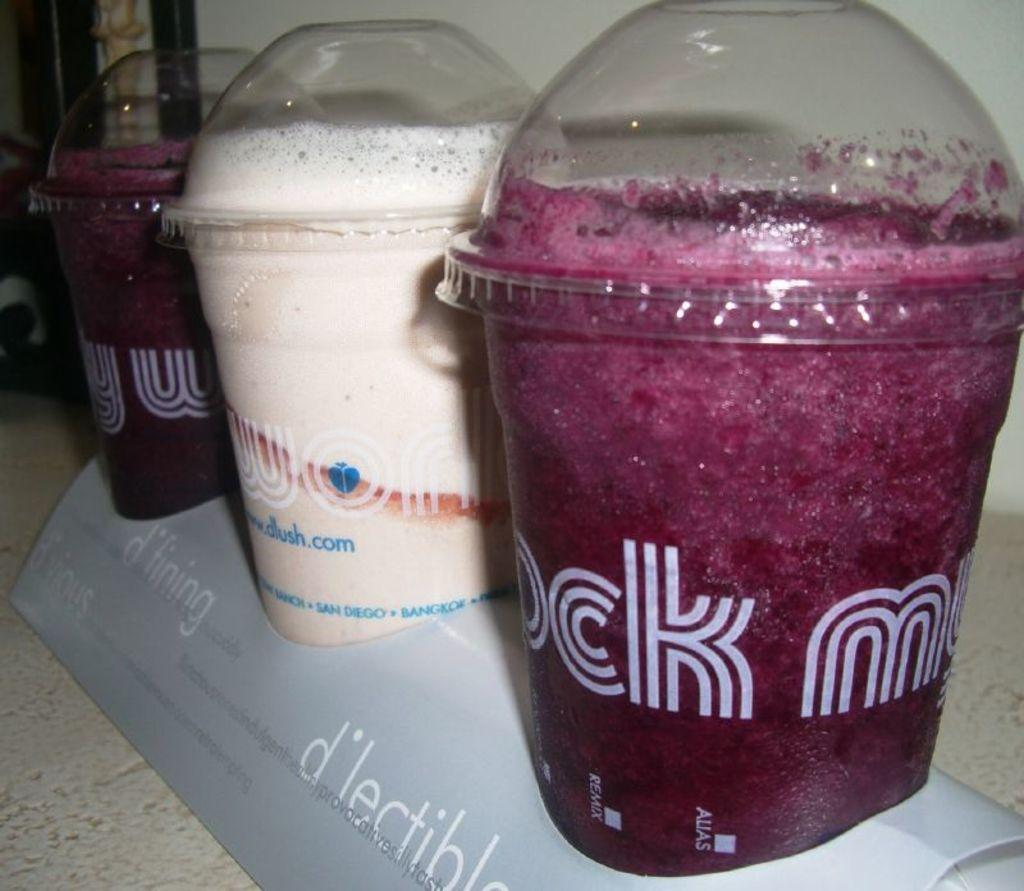<image>
Give a short and clear explanation of the subsequent image. A frozen drink with the letters "ck" on the cup sits in a holder with other drinks. 